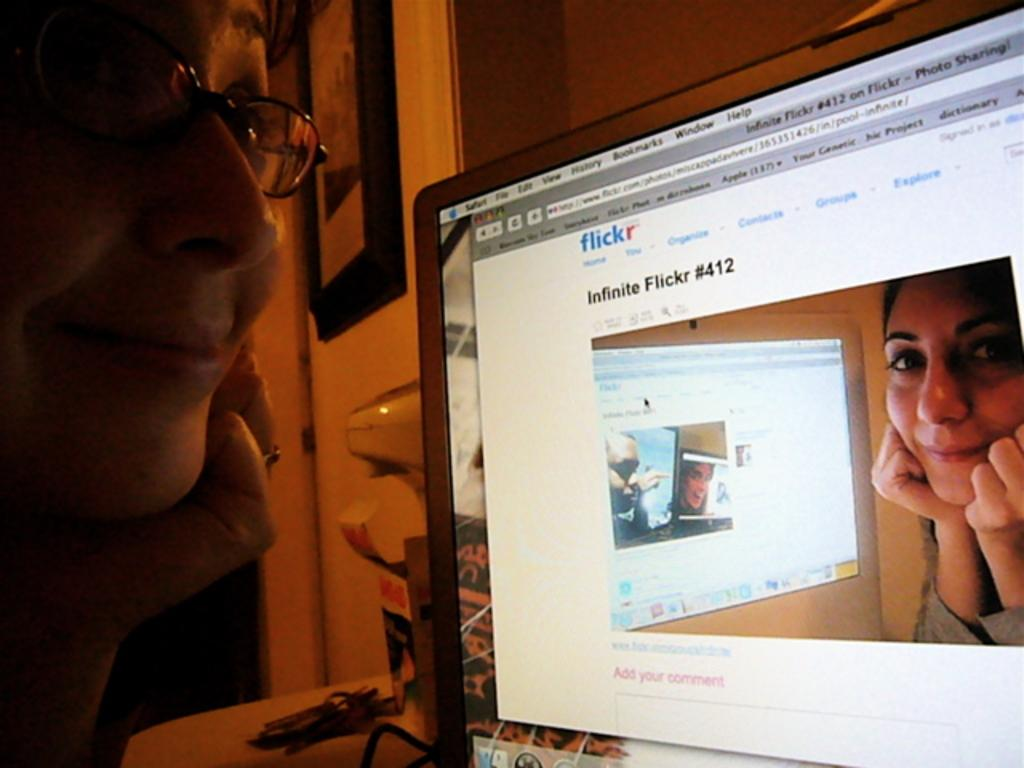What is the main object in the image? There is a screen in the image. Where is the woman located in the image? The woman is on the left side of the image. What can be seen on the table in the image? There are wires on a table in the image. What is hanging on the wall in the image? There is a frame on the wall in the image, as well as other unspecified objects. What type of shoes is the woman wearing in the image? There is no information about the woman's shoes in the image, as the focus is on the screen and other objects. 